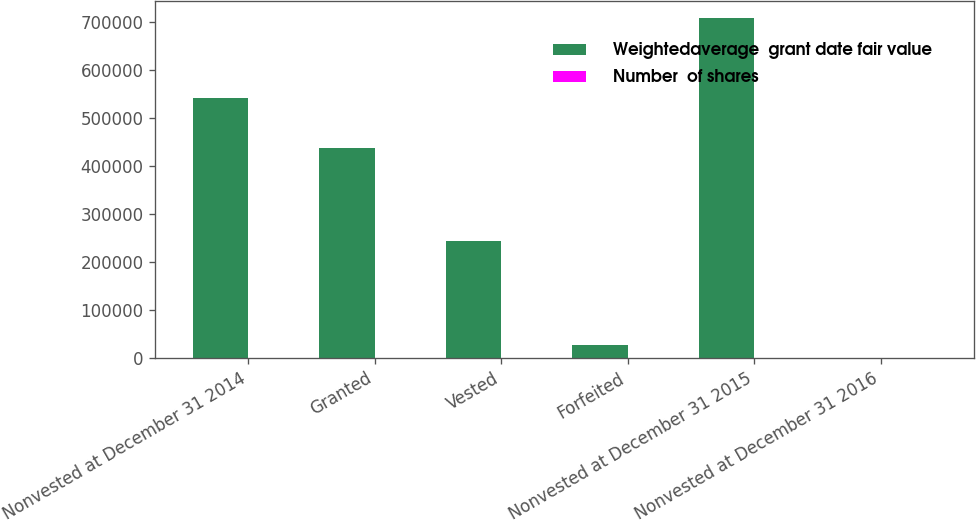Convert chart. <chart><loc_0><loc_0><loc_500><loc_500><stacked_bar_chart><ecel><fcel>Nonvested at December 31 2014<fcel>Granted<fcel>Vested<fcel>Forfeited<fcel>Nonvested at December 31 2015<fcel>Nonvested at December 31 2016<nl><fcel>Weightedaverage  grant date fair value<fcel>542555<fcel>437035<fcel>243423<fcel>26892<fcel>709275<fcel>183.1<nl><fcel>Number  of shares<fcel>130.29<fcel>159.32<fcel>183.1<fcel>148.82<fcel>146.64<fcel>164.62<nl></chart> 